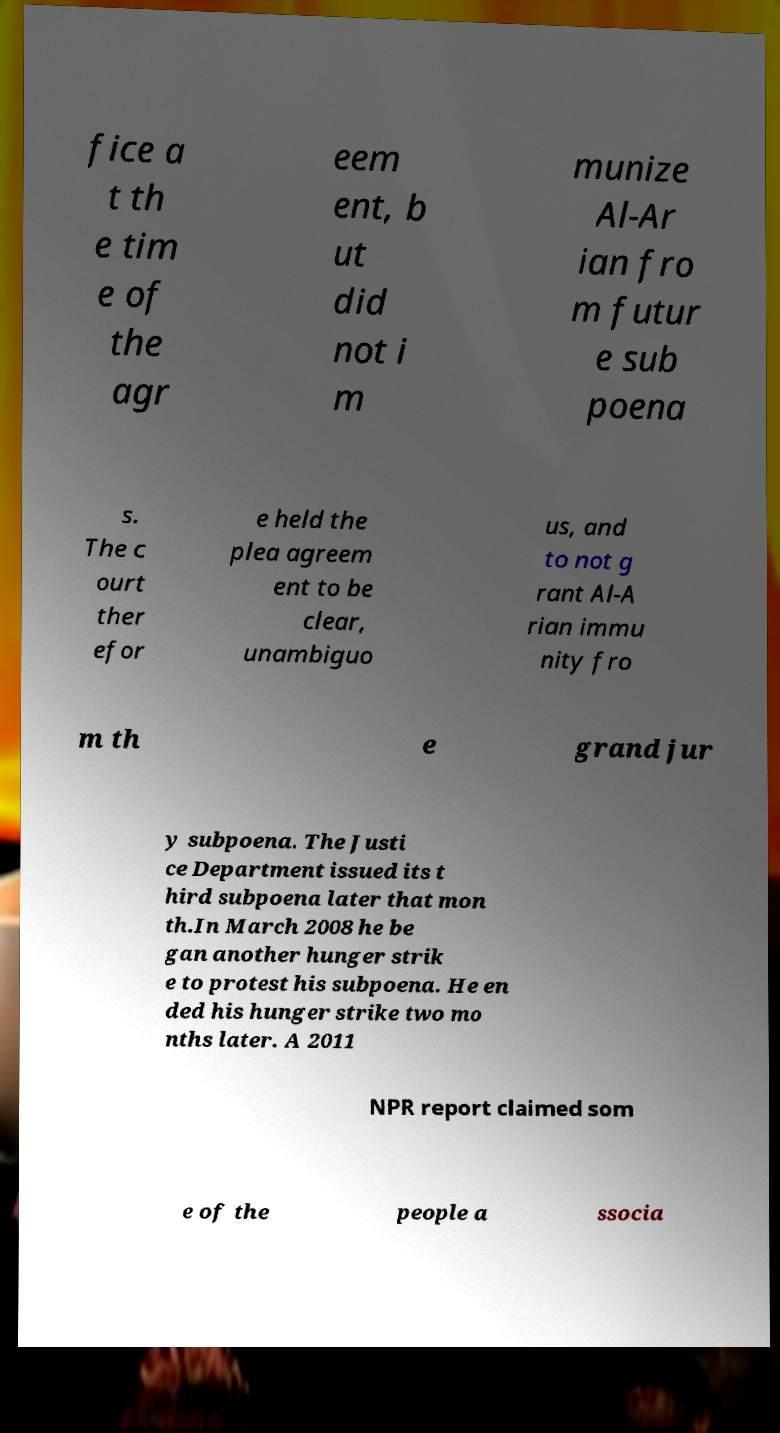Could you extract and type out the text from this image? fice a t th e tim e of the agr eem ent, b ut did not i m munize Al-Ar ian fro m futur e sub poena s. The c ourt ther efor e held the plea agreem ent to be clear, unambiguo us, and to not g rant Al-A rian immu nity fro m th e grand jur y subpoena. The Justi ce Department issued its t hird subpoena later that mon th.In March 2008 he be gan another hunger strik e to protest his subpoena. He en ded his hunger strike two mo nths later. A 2011 NPR report claimed som e of the people a ssocia 